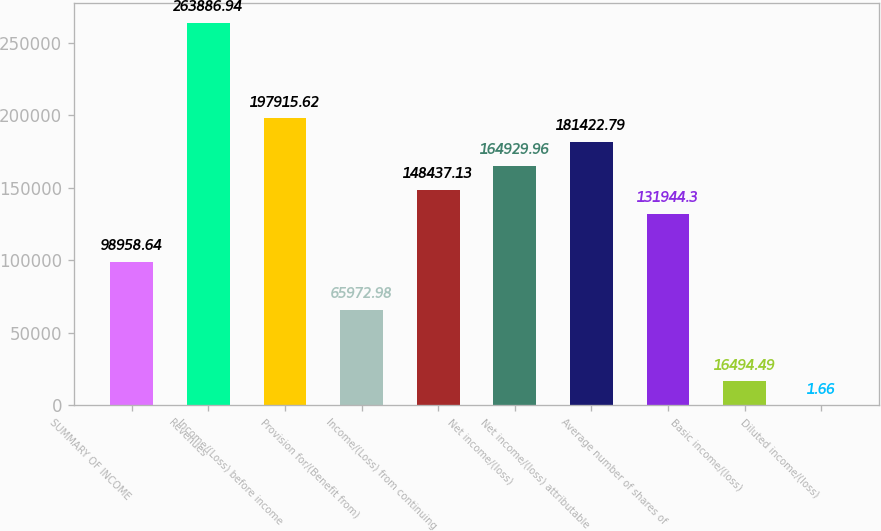<chart> <loc_0><loc_0><loc_500><loc_500><bar_chart><fcel>SUMMARY OF INCOME<fcel>Revenues<fcel>Income/(Loss) before income<fcel>Provision for/(Benefit from)<fcel>Income/(Loss) from continuing<fcel>Net income/(loss)<fcel>Net income/(loss) attributable<fcel>Average number of shares of<fcel>Basic income/(loss)<fcel>Diluted income/(loss)<nl><fcel>98958.6<fcel>263887<fcel>197916<fcel>65973<fcel>148437<fcel>164930<fcel>181423<fcel>131944<fcel>16494.5<fcel>1.66<nl></chart> 